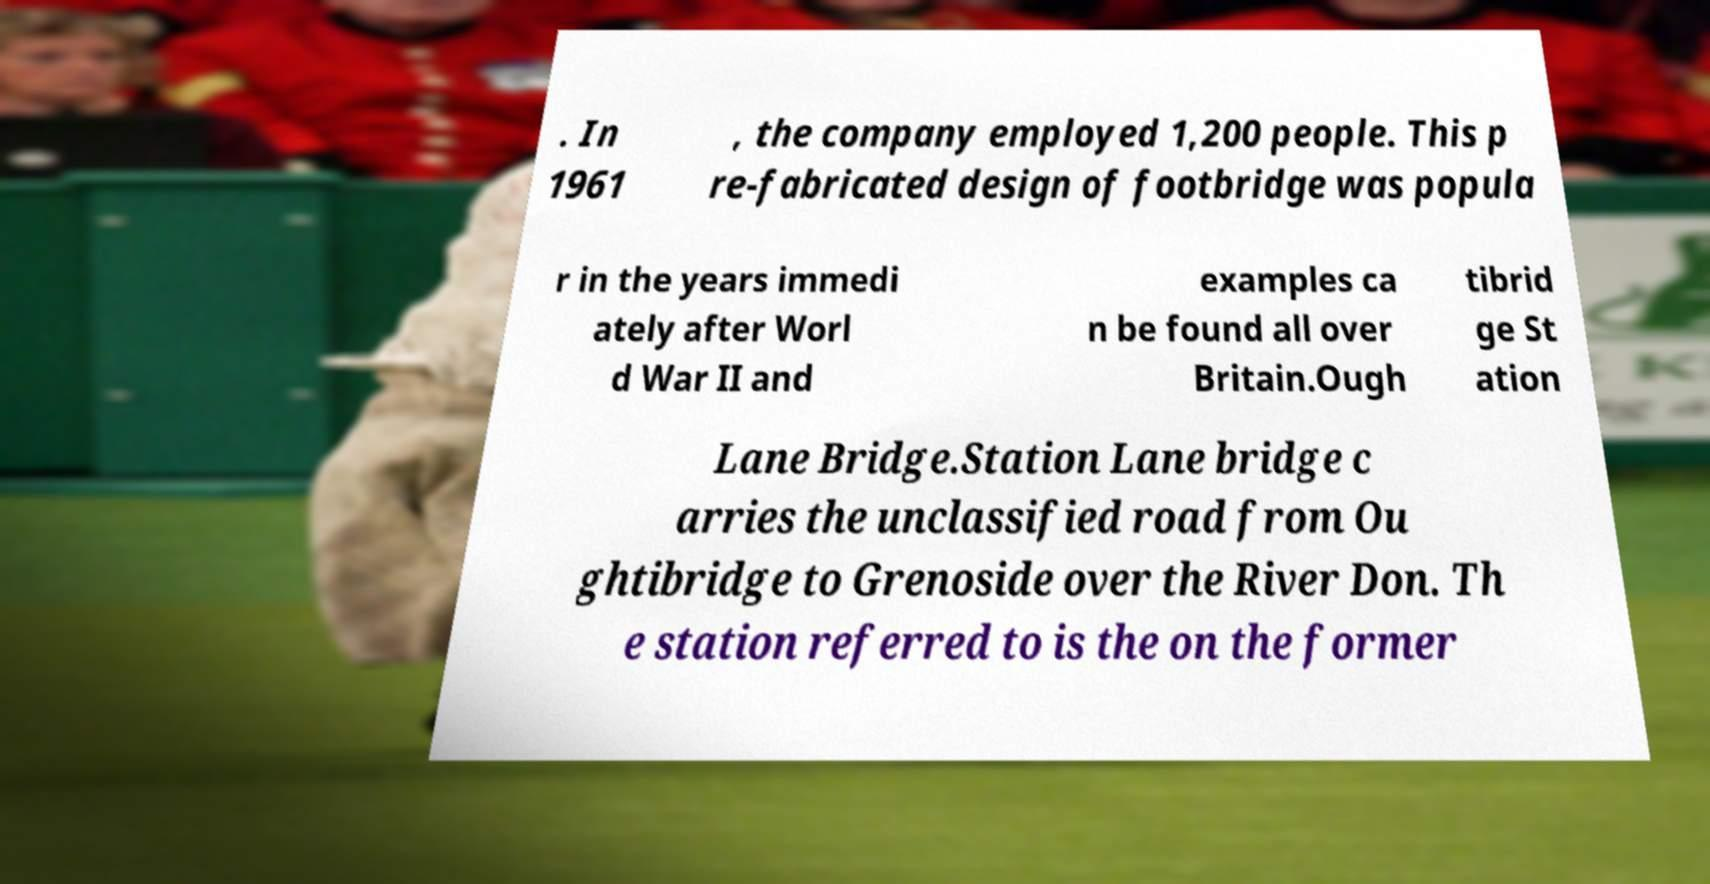Could you assist in decoding the text presented in this image and type it out clearly? . In 1961 , the company employed 1,200 people. This p re-fabricated design of footbridge was popula r in the years immedi ately after Worl d War II and examples ca n be found all over Britain.Ough tibrid ge St ation Lane Bridge.Station Lane bridge c arries the unclassified road from Ou ghtibridge to Grenoside over the River Don. Th e station referred to is the on the former 